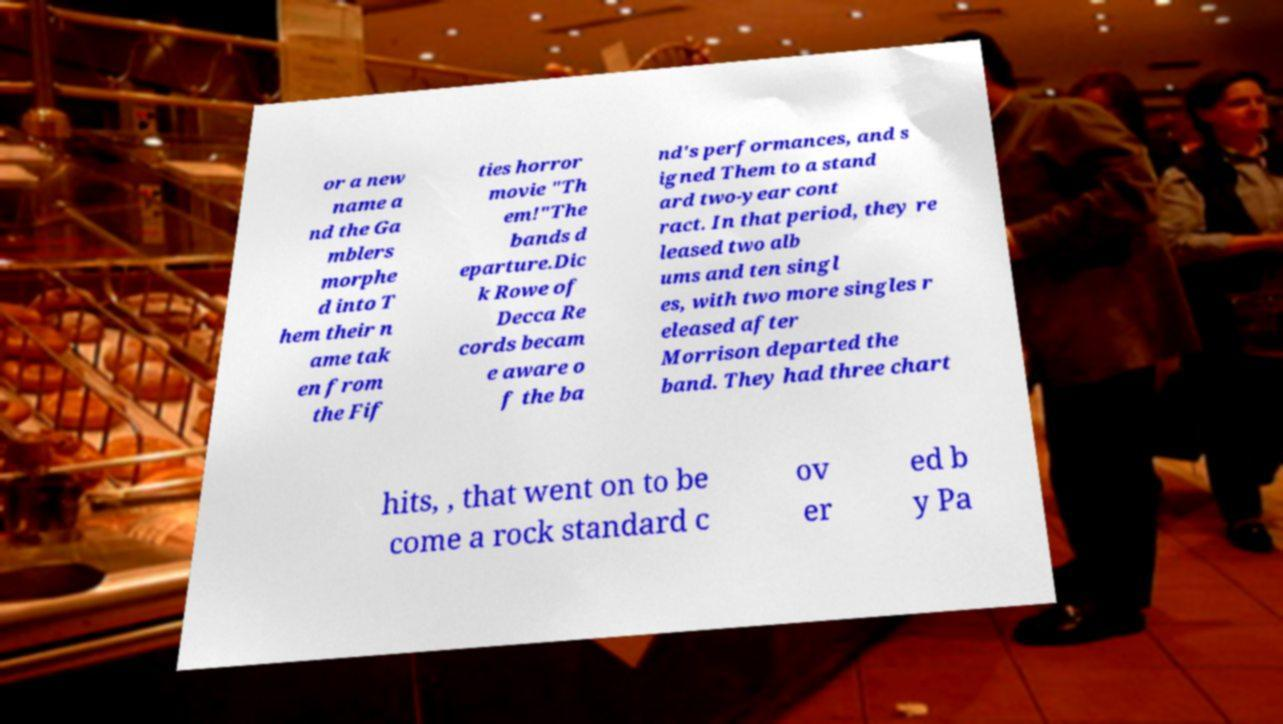Could you assist in decoding the text presented in this image and type it out clearly? or a new name a nd the Ga mblers morphe d into T hem their n ame tak en from the Fif ties horror movie "Th em!"The bands d eparture.Dic k Rowe of Decca Re cords becam e aware o f the ba nd's performances, and s igned Them to a stand ard two-year cont ract. In that period, they re leased two alb ums and ten singl es, with two more singles r eleased after Morrison departed the band. They had three chart hits, , that went on to be come a rock standard c ov er ed b y Pa 